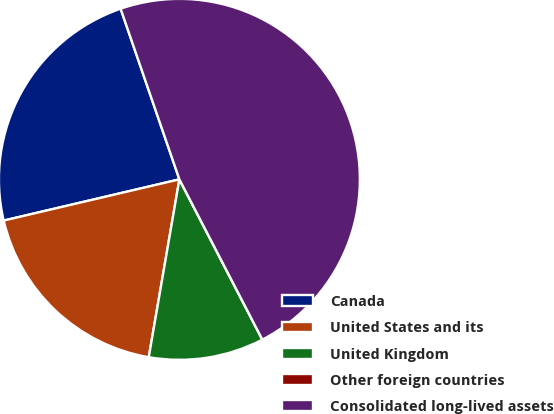Convert chart. <chart><loc_0><loc_0><loc_500><loc_500><pie_chart><fcel>Canada<fcel>United States and its<fcel>United Kingdom<fcel>Other foreign countries<fcel>Consolidated long-lived assets<nl><fcel>23.39%<fcel>18.62%<fcel>10.32%<fcel>0.0%<fcel>47.68%<nl></chart> 